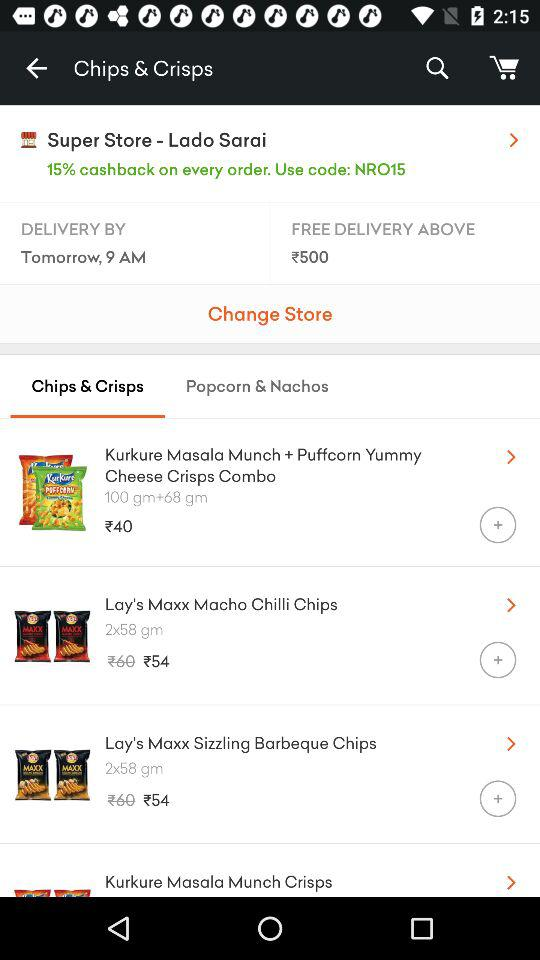When will the order be received? The order will be received by tomorrow at 9 am. 